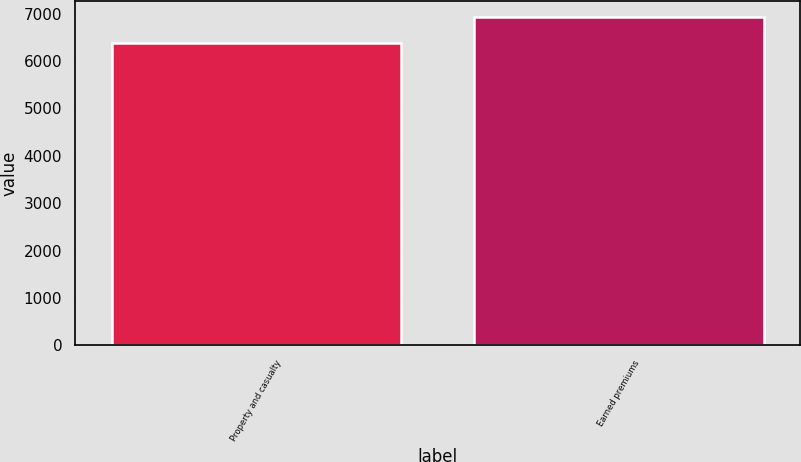Convert chart. <chart><loc_0><loc_0><loc_500><loc_500><bar_chart><fcel>Property and casualty<fcel>Earned premiums<nl><fcel>6373<fcel>6921<nl></chart> 